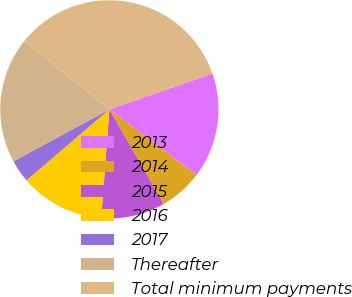Convert chart. <chart><loc_0><loc_0><loc_500><loc_500><pie_chart><fcel>2013<fcel>2014<fcel>2015<fcel>2016<fcel>2017<fcel>Thereafter<fcel>Total minimum payments<nl><fcel>15.6%<fcel>6.43%<fcel>9.48%<fcel>12.54%<fcel>3.37%<fcel>18.65%<fcel>33.93%<nl></chart> 